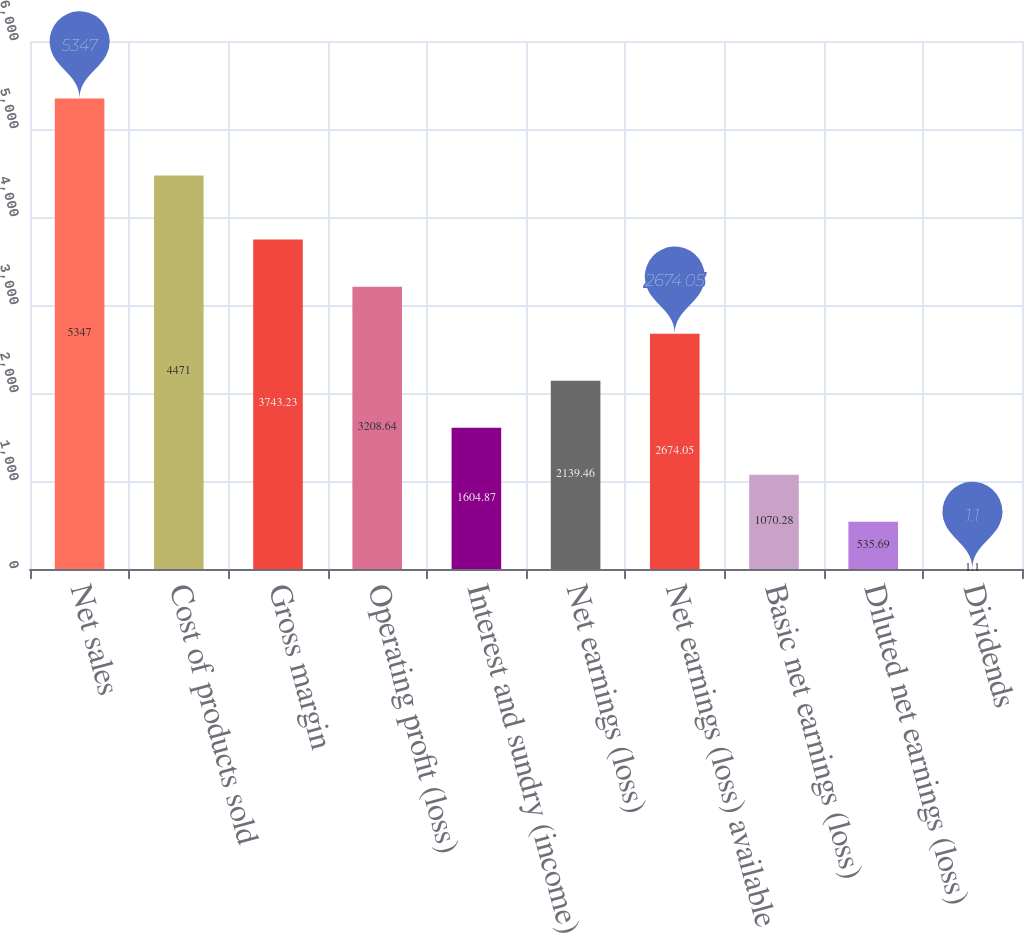Convert chart to OTSL. <chart><loc_0><loc_0><loc_500><loc_500><bar_chart><fcel>Net sales<fcel>Cost of products sold<fcel>Gross margin<fcel>Operating profit (loss)<fcel>Interest and sundry (income)<fcel>Net earnings (loss)<fcel>Net earnings (loss) available<fcel>Basic net earnings (loss)<fcel>Diluted net earnings (loss)<fcel>Dividends<nl><fcel>5347<fcel>4471<fcel>3743.23<fcel>3208.64<fcel>1604.87<fcel>2139.46<fcel>2674.05<fcel>1070.28<fcel>535.69<fcel>1.1<nl></chart> 